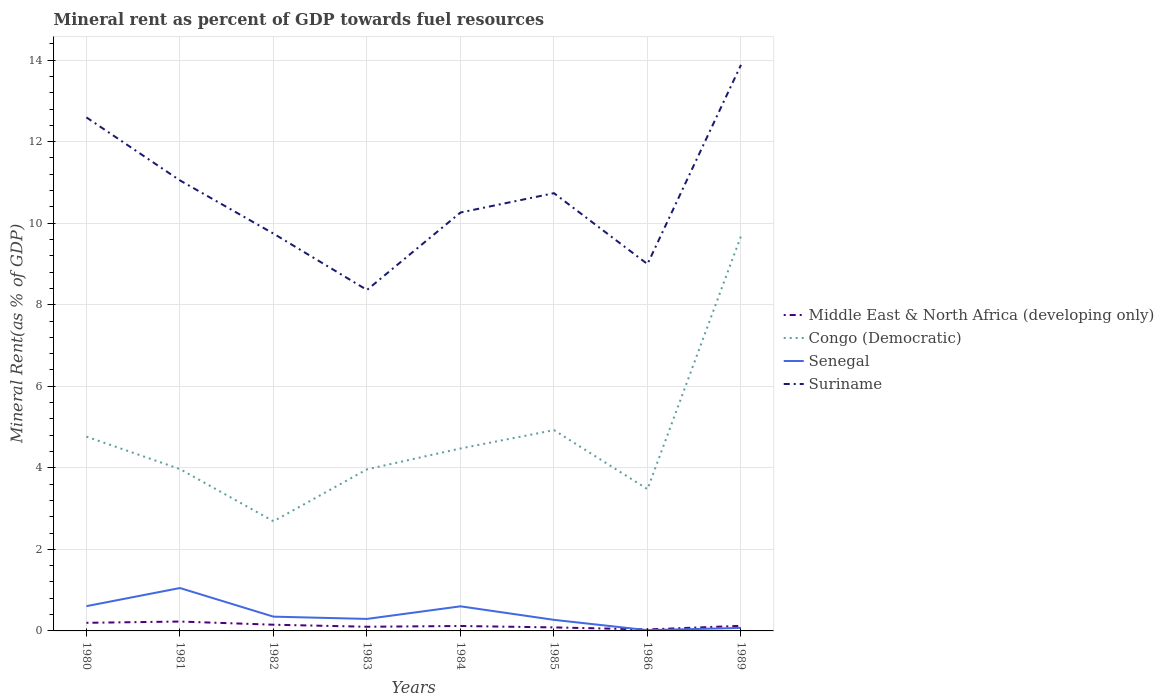How many different coloured lines are there?
Make the answer very short. 4. Is the number of lines equal to the number of legend labels?
Offer a very short reply. Yes. Across all years, what is the maximum mineral rent in Senegal?
Provide a succinct answer. 0.02. What is the total mineral rent in Middle East & North Africa (developing only) in the graph?
Provide a succinct answer. -0.02. What is the difference between the highest and the second highest mineral rent in Senegal?
Make the answer very short. 1.03. What is the difference between the highest and the lowest mineral rent in Senegal?
Offer a very short reply. 3. Does the graph contain any zero values?
Provide a succinct answer. No. Does the graph contain grids?
Offer a terse response. Yes. Where does the legend appear in the graph?
Offer a terse response. Center right. How many legend labels are there?
Provide a short and direct response. 4. How are the legend labels stacked?
Offer a very short reply. Vertical. What is the title of the graph?
Provide a short and direct response. Mineral rent as percent of GDP towards fuel resources. What is the label or title of the X-axis?
Offer a terse response. Years. What is the label or title of the Y-axis?
Make the answer very short. Mineral Rent(as % of GDP). What is the Mineral Rent(as % of GDP) of Middle East & North Africa (developing only) in 1980?
Make the answer very short. 0.2. What is the Mineral Rent(as % of GDP) in Congo (Democratic) in 1980?
Provide a short and direct response. 4.77. What is the Mineral Rent(as % of GDP) in Senegal in 1980?
Keep it short and to the point. 0.61. What is the Mineral Rent(as % of GDP) in Suriname in 1980?
Provide a succinct answer. 12.59. What is the Mineral Rent(as % of GDP) of Middle East & North Africa (developing only) in 1981?
Offer a terse response. 0.23. What is the Mineral Rent(as % of GDP) of Congo (Democratic) in 1981?
Your answer should be compact. 3.97. What is the Mineral Rent(as % of GDP) of Senegal in 1981?
Make the answer very short. 1.05. What is the Mineral Rent(as % of GDP) of Suriname in 1981?
Your response must be concise. 11.05. What is the Mineral Rent(as % of GDP) in Middle East & North Africa (developing only) in 1982?
Your answer should be compact. 0.15. What is the Mineral Rent(as % of GDP) of Congo (Democratic) in 1982?
Ensure brevity in your answer.  2.69. What is the Mineral Rent(as % of GDP) of Senegal in 1982?
Provide a short and direct response. 0.35. What is the Mineral Rent(as % of GDP) of Suriname in 1982?
Provide a short and direct response. 9.74. What is the Mineral Rent(as % of GDP) of Middle East & North Africa (developing only) in 1983?
Ensure brevity in your answer.  0.1. What is the Mineral Rent(as % of GDP) of Congo (Democratic) in 1983?
Offer a very short reply. 3.96. What is the Mineral Rent(as % of GDP) in Senegal in 1983?
Make the answer very short. 0.29. What is the Mineral Rent(as % of GDP) in Suriname in 1983?
Provide a short and direct response. 8.36. What is the Mineral Rent(as % of GDP) in Middle East & North Africa (developing only) in 1984?
Offer a very short reply. 0.12. What is the Mineral Rent(as % of GDP) of Congo (Democratic) in 1984?
Offer a terse response. 4.47. What is the Mineral Rent(as % of GDP) of Senegal in 1984?
Offer a very short reply. 0.6. What is the Mineral Rent(as % of GDP) of Suriname in 1984?
Provide a succinct answer. 10.26. What is the Mineral Rent(as % of GDP) in Middle East & North Africa (developing only) in 1985?
Provide a succinct answer. 0.09. What is the Mineral Rent(as % of GDP) of Congo (Democratic) in 1985?
Give a very brief answer. 4.92. What is the Mineral Rent(as % of GDP) of Senegal in 1985?
Your answer should be very brief. 0.27. What is the Mineral Rent(as % of GDP) in Suriname in 1985?
Keep it short and to the point. 10.74. What is the Mineral Rent(as % of GDP) of Middle East & North Africa (developing only) in 1986?
Your answer should be compact. 0.04. What is the Mineral Rent(as % of GDP) in Congo (Democratic) in 1986?
Provide a short and direct response. 3.48. What is the Mineral Rent(as % of GDP) of Senegal in 1986?
Make the answer very short. 0.02. What is the Mineral Rent(as % of GDP) in Suriname in 1986?
Give a very brief answer. 9. What is the Mineral Rent(as % of GDP) of Middle East & North Africa (developing only) in 1989?
Your response must be concise. 0.13. What is the Mineral Rent(as % of GDP) in Congo (Democratic) in 1989?
Provide a succinct answer. 9.68. What is the Mineral Rent(as % of GDP) in Senegal in 1989?
Provide a short and direct response. 0.07. What is the Mineral Rent(as % of GDP) in Suriname in 1989?
Provide a short and direct response. 13.88. Across all years, what is the maximum Mineral Rent(as % of GDP) of Middle East & North Africa (developing only)?
Your answer should be very brief. 0.23. Across all years, what is the maximum Mineral Rent(as % of GDP) of Congo (Democratic)?
Keep it short and to the point. 9.68. Across all years, what is the maximum Mineral Rent(as % of GDP) in Senegal?
Provide a short and direct response. 1.05. Across all years, what is the maximum Mineral Rent(as % of GDP) in Suriname?
Your answer should be compact. 13.88. Across all years, what is the minimum Mineral Rent(as % of GDP) of Middle East & North Africa (developing only)?
Keep it short and to the point. 0.04. Across all years, what is the minimum Mineral Rent(as % of GDP) in Congo (Democratic)?
Your answer should be very brief. 2.69. Across all years, what is the minimum Mineral Rent(as % of GDP) in Senegal?
Keep it short and to the point. 0.02. Across all years, what is the minimum Mineral Rent(as % of GDP) in Suriname?
Provide a succinct answer. 8.36. What is the total Mineral Rent(as % of GDP) in Middle East & North Africa (developing only) in the graph?
Offer a terse response. 1.05. What is the total Mineral Rent(as % of GDP) of Congo (Democratic) in the graph?
Keep it short and to the point. 37.95. What is the total Mineral Rent(as % of GDP) of Senegal in the graph?
Provide a succinct answer. 3.27. What is the total Mineral Rent(as % of GDP) of Suriname in the graph?
Give a very brief answer. 85.63. What is the difference between the Mineral Rent(as % of GDP) of Middle East & North Africa (developing only) in 1980 and that in 1981?
Offer a terse response. -0.03. What is the difference between the Mineral Rent(as % of GDP) in Congo (Democratic) in 1980 and that in 1981?
Give a very brief answer. 0.8. What is the difference between the Mineral Rent(as % of GDP) in Senegal in 1980 and that in 1981?
Offer a very short reply. -0.44. What is the difference between the Mineral Rent(as % of GDP) of Suriname in 1980 and that in 1981?
Your response must be concise. 1.55. What is the difference between the Mineral Rent(as % of GDP) of Middle East & North Africa (developing only) in 1980 and that in 1982?
Provide a short and direct response. 0.05. What is the difference between the Mineral Rent(as % of GDP) of Congo (Democratic) in 1980 and that in 1982?
Provide a succinct answer. 2.08. What is the difference between the Mineral Rent(as % of GDP) of Senegal in 1980 and that in 1982?
Your answer should be compact. 0.26. What is the difference between the Mineral Rent(as % of GDP) of Suriname in 1980 and that in 1982?
Offer a very short reply. 2.85. What is the difference between the Mineral Rent(as % of GDP) of Middle East & North Africa (developing only) in 1980 and that in 1983?
Provide a succinct answer. 0.1. What is the difference between the Mineral Rent(as % of GDP) in Congo (Democratic) in 1980 and that in 1983?
Give a very brief answer. 0.8. What is the difference between the Mineral Rent(as % of GDP) in Senegal in 1980 and that in 1983?
Offer a very short reply. 0.31. What is the difference between the Mineral Rent(as % of GDP) of Suriname in 1980 and that in 1983?
Your response must be concise. 4.23. What is the difference between the Mineral Rent(as % of GDP) of Middle East & North Africa (developing only) in 1980 and that in 1984?
Keep it short and to the point. 0.08. What is the difference between the Mineral Rent(as % of GDP) of Congo (Democratic) in 1980 and that in 1984?
Make the answer very short. 0.29. What is the difference between the Mineral Rent(as % of GDP) of Senegal in 1980 and that in 1984?
Your response must be concise. 0. What is the difference between the Mineral Rent(as % of GDP) in Suriname in 1980 and that in 1984?
Make the answer very short. 2.33. What is the difference between the Mineral Rent(as % of GDP) of Middle East & North Africa (developing only) in 1980 and that in 1985?
Make the answer very short. 0.11. What is the difference between the Mineral Rent(as % of GDP) of Congo (Democratic) in 1980 and that in 1985?
Your response must be concise. -0.16. What is the difference between the Mineral Rent(as % of GDP) of Senegal in 1980 and that in 1985?
Offer a terse response. 0.34. What is the difference between the Mineral Rent(as % of GDP) in Suriname in 1980 and that in 1985?
Give a very brief answer. 1.86. What is the difference between the Mineral Rent(as % of GDP) of Middle East & North Africa (developing only) in 1980 and that in 1986?
Provide a short and direct response. 0.16. What is the difference between the Mineral Rent(as % of GDP) of Congo (Democratic) in 1980 and that in 1986?
Provide a short and direct response. 1.29. What is the difference between the Mineral Rent(as % of GDP) in Senegal in 1980 and that in 1986?
Provide a succinct answer. 0.59. What is the difference between the Mineral Rent(as % of GDP) in Suriname in 1980 and that in 1986?
Offer a terse response. 3.6. What is the difference between the Mineral Rent(as % of GDP) of Middle East & North Africa (developing only) in 1980 and that in 1989?
Provide a short and direct response. 0.07. What is the difference between the Mineral Rent(as % of GDP) of Congo (Democratic) in 1980 and that in 1989?
Ensure brevity in your answer.  -4.92. What is the difference between the Mineral Rent(as % of GDP) in Senegal in 1980 and that in 1989?
Your answer should be compact. 0.53. What is the difference between the Mineral Rent(as % of GDP) in Suriname in 1980 and that in 1989?
Keep it short and to the point. -1.29. What is the difference between the Mineral Rent(as % of GDP) in Middle East & North Africa (developing only) in 1981 and that in 1982?
Your answer should be very brief. 0.08. What is the difference between the Mineral Rent(as % of GDP) in Congo (Democratic) in 1981 and that in 1982?
Provide a succinct answer. 1.28. What is the difference between the Mineral Rent(as % of GDP) in Senegal in 1981 and that in 1982?
Keep it short and to the point. 0.7. What is the difference between the Mineral Rent(as % of GDP) in Suriname in 1981 and that in 1982?
Offer a terse response. 1.3. What is the difference between the Mineral Rent(as % of GDP) in Middle East & North Africa (developing only) in 1981 and that in 1983?
Provide a short and direct response. 0.13. What is the difference between the Mineral Rent(as % of GDP) of Congo (Democratic) in 1981 and that in 1983?
Provide a succinct answer. 0.01. What is the difference between the Mineral Rent(as % of GDP) in Senegal in 1981 and that in 1983?
Your response must be concise. 0.76. What is the difference between the Mineral Rent(as % of GDP) in Suriname in 1981 and that in 1983?
Offer a terse response. 2.69. What is the difference between the Mineral Rent(as % of GDP) in Middle East & North Africa (developing only) in 1981 and that in 1984?
Your response must be concise. 0.11. What is the difference between the Mineral Rent(as % of GDP) in Congo (Democratic) in 1981 and that in 1984?
Give a very brief answer. -0.51. What is the difference between the Mineral Rent(as % of GDP) of Senegal in 1981 and that in 1984?
Offer a terse response. 0.45. What is the difference between the Mineral Rent(as % of GDP) of Suriname in 1981 and that in 1984?
Make the answer very short. 0.79. What is the difference between the Mineral Rent(as % of GDP) of Middle East & North Africa (developing only) in 1981 and that in 1985?
Make the answer very short. 0.14. What is the difference between the Mineral Rent(as % of GDP) of Congo (Democratic) in 1981 and that in 1985?
Your response must be concise. -0.95. What is the difference between the Mineral Rent(as % of GDP) in Senegal in 1981 and that in 1985?
Offer a very short reply. 0.78. What is the difference between the Mineral Rent(as % of GDP) of Suriname in 1981 and that in 1985?
Ensure brevity in your answer.  0.31. What is the difference between the Mineral Rent(as % of GDP) of Middle East & North Africa (developing only) in 1981 and that in 1986?
Offer a very short reply. 0.19. What is the difference between the Mineral Rent(as % of GDP) of Congo (Democratic) in 1981 and that in 1986?
Your answer should be very brief. 0.49. What is the difference between the Mineral Rent(as % of GDP) of Senegal in 1981 and that in 1986?
Your answer should be very brief. 1.03. What is the difference between the Mineral Rent(as % of GDP) in Suriname in 1981 and that in 1986?
Offer a terse response. 2.05. What is the difference between the Mineral Rent(as % of GDP) in Middle East & North Africa (developing only) in 1981 and that in 1989?
Offer a terse response. 0.1. What is the difference between the Mineral Rent(as % of GDP) of Congo (Democratic) in 1981 and that in 1989?
Provide a succinct answer. -5.71. What is the difference between the Mineral Rent(as % of GDP) in Senegal in 1981 and that in 1989?
Keep it short and to the point. 0.98. What is the difference between the Mineral Rent(as % of GDP) of Suriname in 1981 and that in 1989?
Your answer should be compact. -2.83. What is the difference between the Mineral Rent(as % of GDP) of Middle East & North Africa (developing only) in 1982 and that in 1983?
Make the answer very short. 0.05. What is the difference between the Mineral Rent(as % of GDP) in Congo (Democratic) in 1982 and that in 1983?
Make the answer very short. -1.27. What is the difference between the Mineral Rent(as % of GDP) in Senegal in 1982 and that in 1983?
Provide a short and direct response. 0.06. What is the difference between the Mineral Rent(as % of GDP) in Suriname in 1982 and that in 1983?
Keep it short and to the point. 1.38. What is the difference between the Mineral Rent(as % of GDP) in Middle East & North Africa (developing only) in 1982 and that in 1984?
Offer a terse response. 0.03. What is the difference between the Mineral Rent(as % of GDP) of Congo (Democratic) in 1982 and that in 1984?
Offer a very short reply. -1.79. What is the difference between the Mineral Rent(as % of GDP) of Senegal in 1982 and that in 1984?
Provide a short and direct response. -0.25. What is the difference between the Mineral Rent(as % of GDP) in Suriname in 1982 and that in 1984?
Your answer should be very brief. -0.52. What is the difference between the Mineral Rent(as % of GDP) in Middle East & North Africa (developing only) in 1982 and that in 1985?
Give a very brief answer. 0.07. What is the difference between the Mineral Rent(as % of GDP) of Congo (Democratic) in 1982 and that in 1985?
Make the answer very short. -2.24. What is the difference between the Mineral Rent(as % of GDP) in Senegal in 1982 and that in 1985?
Offer a very short reply. 0.08. What is the difference between the Mineral Rent(as % of GDP) of Suriname in 1982 and that in 1985?
Give a very brief answer. -0.99. What is the difference between the Mineral Rent(as % of GDP) in Middle East & North Africa (developing only) in 1982 and that in 1986?
Your answer should be compact. 0.12. What is the difference between the Mineral Rent(as % of GDP) in Congo (Democratic) in 1982 and that in 1986?
Offer a terse response. -0.79. What is the difference between the Mineral Rent(as % of GDP) in Senegal in 1982 and that in 1986?
Your response must be concise. 0.33. What is the difference between the Mineral Rent(as % of GDP) of Suriname in 1982 and that in 1986?
Keep it short and to the point. 0.75. What is the difference between the Mineral Rent(as % of GDP) of Middle East & North Africa (developing only) in 1982 and that in 1989?
Make the answer very short. 0.03. What is the difference between the Mineral Rent(as % of GDP) of Congo (Democratic) in 1982 and that in 1989?
Your answer should be compact. -6.99. What is the difference between the Mineral Rent(as % of GDP) in Senegal in 1982 and that in 1989?
Offer a very short reply. 0.28. What is the difference between the Mineral Rent(as % of GDP) of Suriname in 1982 and that in 1989?
Provide a succinct answer. -4.14. What is the difference between the Mineral Rent(as % of GDP) of Middle East & North Africa (developing only) in 1983 and that in 1984?
Ensure brevity in your answer.  -0.02. What is the difference between the Mineral Rent(as % of GDP) of Congo (Democratic) in 1983 and that in 1984?
Offer a very short reply. -0.51. What is the difference between the Mineral Rent(as % of GDP) of Senegal in 1983 and that in 1984?
Provide a succinct answer. -0.31. What is the difference between the Mineral Rent(as % of GDP) of Suriname in 1983 and that in 1984?
Your response must be concise. -1.9. What is the difference between the Mineral Rent(as % of GDP) in Middle East & North Africa (developing only) in 1983 and that in 1985?
Make the answer very short. 0.02. What is the difference between the Mineral Rent(as % of GDP) of Congo (Democratic) in 1983 and that in 1985?
Your answer should be compact. -0.96. What is the difference between the Mineral Rent(as % of GDP) of Senegal in 1983 and that in 1985?
Your response must be concise. 0.02. What is the difference between the Mineral Rent(as % of GDP) of Suriname in 1983 and that in 1985?
Provide a succinct answer. -2.37. What is the difference between the Mineral Rent(as % of GDP) of Middle East & North Africa (developing only) in 1983 and that in 1986?
Provide a succinct answer. 0.07. What is the difference between the Mineral Rent(as % of GDP) of Congo (Democratic) in 1983 and that in 1986?
Offer a very short reply. 0.49. What is the difference between the Mineral Rent(as % of GDP) in Senegal in 1983 and that in 1986?
Your response must be concise. 0.28. What is the difference between the Mineral Rent(as % of GDP) of Suriname in 1983 and that in 1986?
Your response must be concise. -0.64. What is the difference between the Mineral Rent(as % of GDP) of Middle East & North Africa (developing only) in 1983 and that in 1989?
Provide a short and direct response. -0.02. What is the difference between the Mineral Rent(as % of GDP) in Congo (Democratic) in 1983 and that in 1989?
Your answer should be very brief. -5.72. What is the difference between the Mineral Rent(as % of GDP) in Senegal in 1983 and that in 1989?
Provide a short and direct response. 0.22. What is the difference between the Mineral Rent(as % of GDP) of Suriname in 1983 and that in 1989?
Keep it short and to the point. -5.52. What is the difference between the Mineral Rent(as % of GDP) in Middle East & North Africa (developing only) in 1984 and that in 1985?
Make the answer very short. 0.03. What is the difference between the Mineral Rent(as % of GDP) of Congo (Democratic) in 1984 and that in 1985?
Ensure brevity in your answer.  -0.45. What is the difference between the Mineral Rent(as % of GDP) in Senegal in 1984 and that in 1985?
Offer a terse response. 0.33. What is the difference between the Mineral Rent(as % of GDP) of Suriname in 1984 and that in 1985?
Ensure brevity in your answer.  -0.47. What is the difference between the Mineral Rent(as % of GDP) of Middle East & North Africa (developing only) in 1984 and that in 1986?
Give a very brief answer. 0.08. What is the difference between the Mineral Rent(as % of GDP) of Senegal in 1984 and that in 1986?
Your answer should be compact. 0.59. What is the difference between the Mineral Rent(as % of GDP) of Suriname in 1984 and that in 1986?
Provide a succinct answer. 1.26. What is the difference between the Mineral Rent(as % of GDP) in Middle East & North Africa (developing only) in 1984 and that in 1989?
Your answer should be very brief. -0. What is the difference between the Mineral Rent(as % of GDP) in Congo (Democratic) in 1984 and that in 1989?
Your response must be concise. -5.21. What is the difference between the Mineral Rent(as % of GDP) of Senegal in 1984 and that in 1989?
Your answer should be very brief. 0.53. What is the difference between the Mineral Rent(as % of GDP) of Suriname in 1984 and that in 1989?
Offer a very short reply. -3.62. What is the difference between the Mineral Rent(as % of GDP) of Middle East & North Africa (developing only) in 1985 and that in 1986?
Your answer should be compact. 0.05. What is the difference between the Mineral Rent(as % of GDP) of Congo (Democratic) in 1985 and that in 1986?
Make the answer very short. 1.45. What is the difference between the Mineral Rent(as % of GDP) of Senegal in 1985 and that in 1986?
Make the answer very short. 0.25. What is the difference between the Mineral Rent(as % of GDP) of Suriname in 1985 and that in 1986?
Your answer should be very brief. 1.74. What is the difference between the Mineral Rent(as % of GDP) in Middle East & North Africa (developing only) in 1985 and that in 1989?
Make the answer very short. -0.04. What is the difference between the Mineral Rent(as % of GDP) in Congo (Democratic) in 1985 and that in 1989?
Provide a short and direct response. -4.76. What is the difference between the Mineral Rent(as % of GDP) in Senegal in 1985 and that in 1989?
Provide a short and direct response. 0.2. What is the difference between the Mineral Rent(as % of GDP) in Suriname in 1985 and that in 1989?
Offer a terse response. -3.15. What is the difference between the Mineral Rent(as % of GDP) of Middle East & North Africa (developing only) in 1986 and that in 1989?
Make the answer very short. -0.09. What is the difference between the Mineral Rent(as % of GDP) in Congo (Democratic) in 1986 and that in 1989?
Ensure brevity in your answer.  -6.21. What is the difference between the Mineral Rent(as % of GDP) in Senegal in 1986 and that in 1989?
Make the answer very short. -0.06. What is the difference between the Mineral Rent(as % of GDP) in Suriname in 1986 and that in 1989?
Provide a short and direct response. -4.89. What is the difference between the Mineral Rent(as % of GDP) in Middle East & North Africa (developing only) in 1980 and the Mineral Rent(as % of GDP) in Congo (Democratic) in 1981?
Your response must be concise. -3.77. What is the difference between the Mineral Rent(as % of GDP) of Middle East & North Africa (developing only) in 1980 and the Mineral Rent(as % of GDP) of Senegal in 1981?
Provide a succinct answer. -0.85. What is the difference between the Mineral Rent(as % of GDP) in Middle East & North Africa (developing only) in 1980 and the Mineral Rent(as % of GDP) in Suriname in 1981?
Make the answer very short. -10.85. What is the difference between the Mineral Rent(as % of GDP) of Congo (Democratic) in 1980 and the Mineral Rent(as % of GDP) of Senegal in 1981?
Give a very brief answer. 3.71. What is the difference between the Mineral Rent(as % of GDP) in Congo (Democratic) in 1980 and the Mineral Rent(as % of GDP) in Suriname in 1981?
Your answer should be compact. -6.28. What is the difference between the Mineral Rent(as % of GDP) in Senegal in 1980 and the Mineral Rent(as % of GDP) in Suriname in 1981?
Provide a short and direct response. -10.44. What is the difference between the Mineral Rent(as % of GDP) in Middle East & North Africa (developing only) in 1980 and the Mineral Rent(as % of GDP) in Congo (Democratic) in 1982?
Give a very brief answer. -2.49. What is the difference between the Mineral Rent(as % of GDP) in Middle East & North Africa (developing only) in 1980 and the Mineral Rent(as % of GDP) in Senegal in 1982?
Your answer should be very brief. -0.15. What is the difference between the Mineral Rent(as % of GDP) of Middle East & North Africa (developing only) in 1980 and the Mineral Rent(as % of GDP) of Suriname in 1982?
Your response must be concise. -9.55. What is the difference between the Mineral Rent(as % of GDP) of Congo (Democratic) in 1980 and the Mineral Rent(as % of GDP) of Senegal in 1982?
Provide a succinct answer. 4.42. What is the difference between the Mineral Rent(as % of GDP) of Congo (Democratic) in 1980 and the Mineral Rent(as % of GDP) of Suriname in 1982?
Offer a terse response. -4.98. What is the difference between the Mineral Rent(as % of GDP) of Senegal in 1980 and the Mineral Rent(as % of GDP) of Suriname in 1982?
Your answer should be compact. -9.14. What is the difference between the Mineral Rent(as % of GDP) in Middle East & North Africa (developing only) in 1980 and the Mineral Rent(as % of GDP) in Congo (Democratic) in 1983?
Your response must be concise. -3.76. What is the difference between the Mineral Rent(as % of GDP) in Middle East & North Africa (developing only) in 1980 and the Mineral Rent(as % of GDP) in Senegal in 1983?
Your answer should be very brief. -0.1. What is the difference between the Mineral Rent(as % of GDP) of Middle East & North Africa (developing only) in 1980 and the Mineral Rent(as % of GDP) of Suriname in 1983?
Ensure brevity in your answer.  -8.16. What is the difference between the Mineral Rent(as % of GDP) in Congo (Democratic) in 1980 and the Mineral Rent(as % of GDP) in Senegal in 1983?
Your answer should be very brief. 4.47. What is the difference between the Mineral Rent(as % of GDP) of Congo (Democratic) in 1980 and the Mineral Rent(as % of GDP) of Suriname in 1983?
Your answer should be very brief. -3.6. What is the difference between the Mineral Rent(as % of GDP) in Senegal in 1980 and the Mineral Rent(as % of GDP) in Suriname in 1983?
Your answer should be compact. -7.75. What is the difference between the Mineral Rent(as % of GDP) in Middle East & North Africa (developing only) in 1980 and the Mineral Rent(as % of GDP) in Congo (Democratic) in 1984?
Your answer should be compact. -4.28. What is the difference between the Mineral Rent(as % of GDP) in Middle East & North Africa (developing only) in 1980 and the Mineral Rent(as % of GDP) in Senegal in 1984?
Offer a very short reply. -0.4. What is the difference between the Mineral Rent(as % of GDP) of Middle East & North Africa (developing only) in 1980 and the Mineral Rent(as % of GDP) of Suriname in 1984?
Make the answer very short. -10.06. What is the difference between the Mineral Rent(as % of GDP) of Congo (Democratic) in 1980 and the Mineral Rent(as % of GDP) of Senegal in 1984?
Offer a terse response. 4.16. What is the difference between the Mineral Rent(as % of GDP) of Congo (Democratic) in 1980 and the Mineral Rent(as % of GDP) of Suriname in 1984?
Your answer should be very brief. -5.5. What is the difference between the Mineral Rent(as % of GDP) of Senegal in 1980 and the Mineral Rent(as % of GDP) of Suriname in 1984?
Ensure brevity in your answer.  -9.65. What is the difference between the Mineral Rent(as % of GDP) in Middle East & North Africa (developing only) in 1980 and the Mineral Rent(as % of GDP) in Congo (Democratic) in 1985?
Provide a short and direct response. -4.73. What is the difference between the Mineral Rent(as % of GDP) of Middle East & North Africa (developing only) in 1980 and the Mineral Rent(as % of GDP) of Senegal in 1985?
Your response must be concise. -0.07. What is the difference between the Mineral Rent(as % of GDP) in Middle East & North Africa (developing only) in 1980 and the Mineral Rent(as % of GDP) in Suriname in 1985?
Ensure brevity in your answer.  -10.54. What is the difference between the Mineral Rent(as % of GDP) in Congo (Democratic) in 1980 and the Mineral Rent(as % of GDP) in Senegal in 1985?
Make the answer very short. 4.49. What is the difference between the Mineral Rent(as % of GDP) in Congo (Democratic) in 1980 and the Mineral Rent(as % of GDP) in Suriname in 1985?
Give a very brief answer. -5.97. What is the difference between the Mineral Rent(as % of GDP) of Senegal in 1980 and the Mineral Rent(as % of GDP) of Suriname in 1985?
Offer a very short reply. -10.13. What is the difference between the Mineral Rent(as % of GDP) in Middle East & North Africa (developing only) in 1980 and the Mineral Rent(as % of GDP) in Congo (Democratic) in 1986?
Your answer should be very brief. -3.28. What is the difference between the Mineral Rent(as % of GDP) of Middle East & North Africa (developing only) in 1980 and the Mineral Rent(as % of GDP) of Senegal in 1986?
Your answer should be compact. 0.18. What is the difference between the Mineral Rent(as % of GDP) of Middle East & North Africa (developing only) in 1980 and the Mineral Rent(as % of GDP) of Suriname in 1986?
Ensure brevity in your answer.  -8.8. What is the difference between the Mineral Rent(as % of GDP) of Congo (Democratic) in 1980 and the Mineral Rent(as % of GDP) of Senegal in 1986?
Your response must be concise. 4.75. What is the difference between the Mineral Rent(as % of GDP) of Congo (Democratic) in 1980 and the Mineral Rent(as % of GDP) of Suriname in 1986?
Offer a very short reply. -4.23. What is the difference between the Mineral Rent(as % of GDP) of Senegal in 1980 and the Mineral Rent(as % of GDP) of Suriname in 1986?
Keep it short and to the point. -8.39. What is the difference between the Mineral Rent(as % of GDP) in Middle East & North Africa (developing only) in 1980 and the Mineral Rent(as % of GDP) in Congo (Democratic) in 1989?
Offer a very short reply. -9.48. What is the difference between the Mineral Rent(as % of GDP) of Middle East & North Africa (developing only) in 1980 and the Mineral Rent(as % of GDP) of Senegal in 1989?
Make the answer very short. 0.12. What is the difference between the Mineral Rent(as % of GDP) of Middle East & North Africa (developing only) in 1980 and the Mineral Rent(as % of GDP) of Suriname in 1989?
Keep it short and to the point. -13.68. What is the difference between the Mineral Rent(as % of GDP) in Congo (Democratic) in 1980 and the Mineral Rent(as % of GDP) in Senegal in 1989?
Provide a short and direct response. 4.69. What is the difference between the Mineral Rent(as % of GDP) in Congo (Democratic) in 1980 and the Mineral Rent(as % of GDP) in Suriname in 1989?
Give a very brief answer. -9.12. What is the difference between the Mineral Rent(as % of GDP) in Senegal in 1980 and the Mineral Rent(as % of GDP) in Suriname in 1989?
Provide a succinct answer. -13.28. What is the difference between the Mineral Rent(as % of GDP) in Middle East & North Africa (developing only) in 1981 and the Mineral Rent(as % of GDP) in Congo (Democratic) in 1982?
Your answer should be compact. -2.46. What is the difference between the Mineral Rent(as % of GDP) of Middle East & North Africa (developing only) in 1981 and the Mineral Rent(as % of GDP) of Senegal in 1982?
Give a very brief answer. -0.12. What is the difference between the Mineral Rent(as % of GDP) of Middle East & North Africa (developing only) in 1981 and the Mineral Rent(as % of GDP) of Suriname in 1982?
Ensure brevity in your answer.  -9.51. What is the difference between the Mineral Rent(as % of GDP) of Congo (Democratic) in 1981 and the Mineral Rent(as % of GDP) of Senegal in 1982?
Your answer should be compact. 3.62. What is the difference between the Mineral Rent(as % of GDP) in Congo (Democratic) in 1981 and the Mineral Rent(as % of GDP) in Suriname in 1982?
Offer a terse response. -5.78. What is the difference between the Mineral Rent(as % of GDP) of Senegal in 1981 and the Mineral Rent(as % of GDP) of Suriname in 1982?
Your response must be concise. -8.69. What is the difference between the Mineral Rent(as % of GDP) in Middle East & North Africa (developing only) in 1981 and the Mineral Rent(as % of GDP) in Congo (Democratic) in 1983?
Your response must be concise. -3.73. What is the difference between the Mineral Rent(as % of GDP) in Middle East & North Africa (developing only) in 1981 and the Mineral Rent(as % of GDP) in Senegal in 1983?
Your answer should be very brief. -0.06. What is the difference between the Mineral Rent(as % of GDP) of Middle East & North Africa (developing only) in 1981 and the Mineral Rent(as % of GDP) of Suriname in 1983?
Offer a terse response. -8.13. What is the difference between the Mineral Rent(as % of GDP) of Congo (Democratic) in 1981 and the Mineral Rent(as % of GDP) of Senegal in 1983?
Offer a terse response. 3.68. What is the difference between the Mineral Rent(as % of GDP) of Congo (Democratic) in 1981 and the Mineral Rent(as % of GDP) of Suriname in 1983?
Your response must be concise. -4.39. What is the difference between the Mineral Rent(as % of GDP) in Senegal in 1981 and the Mineral Rent(as % of GDP) in Suriname in 1983?
Your answer should be very brief. -7.31. What is the difference between the Mineral Rent(as % of GDP) of Middle East & North Africa (developing only) in 1981 and the Mineral Rent(as % of GDP) of Congo (Democratic) in 1984?
Your answer should be very brief. -4.24. What is the difference between the Mineral Rent(as % of GDP) of Middle East & North Africa (developing only) in 1981 and the Mineral Rent(as % of GDP) of Senegal in 1984?
Keep it short and to the point. -0.37. What is the difference between the Mineral Rent(as % of GDP) of Middle East & North Africa (developing only) in 1981 and the Mineral Rent(as % of GDP) of Suriname in 1984?
Provide a short and direct response. -10.03. What is the difference between the Mineral Rent(as % of GDP) in Congo (Democratic) in 1981 and the Mineral Rent(as % of GDP) in Senegal in 1984?
Make the answer very short. 3.37. What is the difference between the Mineral Rent(as % of GDP) in Congo (Democratic) in 1981 and the Mineral Rent(as % of GDP) in Suriname in 1984?
Your response must be concise. -6.29. What is the difference between the Mineral Rent(as % of GDP) of Senegal in 1981 and the Mineral Rent(as % of GDP) of Suriname in 1984?
Keep it short and to the point. -9.21. What is the difference between the Mineral Rent(as % of GDP) in Middle East & North Africa (developing only) in 1981 and the Mineral Rent(as % of GDP) in Congo (Democratic) in 1985?
Ensure brevity in your answer.  -4.69. What is the difference between the Mineral Rent(as % of GDP) of Middle East & North Africa (developing only) in 1981 and the Mineral Rent(as % of GDP) of Senegal in 1985?
Your answer should be compact. -0.04. What is the difference between the Mineral Rent(as % of GDP) of Middle East & North Africa (developing only) in 1981 and the Mineral Rent(as % of GDP) of Suriname in 1985?
Provide a succinct answer. -10.51. What is the difference between the Mineral Rent(as % of GDP) in Congo (Democratic) in 1981 and the Mineral Rent(as % of GDP) in Senegal in 1985?
Give a very brief answer. 3.7. What is the difference between the Mineral Rent(as % of GDP) in Congo (Democratic) in 1981 and the Mineral Rent(as % of GDP) in Suriname in 1985?
Make the answer very short. -6.77. What is the difference between the Mineral Rent(as % of GDP) of Senegal in 1981 and the Mineral Rent(as % of GDP) of Suriname in 1985?
Make the answer very short. -9.68. What is the difference between the Mineral Rent(as % of GDP) in Middle East & North Africa (developing only) in 1981 and the Mineral Rent(as % of GDP) in Congo (Democratic) in 1986?
Provide a succinct answer. -3.25. What is the difference between the Mineral Rent(as % of GDP) in Middle East & North Africa (developing only) in 1981 and the Mineral Rent(as % of GDP) in Senegal in 1986?
Provide a short and direct response. 0.21. What is the difference between the Mineral Rent(as % of GDP) in Middle East & North Africa (developing only) in 1981 and the Mineral Rent(as % of GDP) in Suriname in 1986?
Give a very brief answer. -8.77. What is the difference between the Mineral Rent(as % of GDP) of Congo (Democratic) in 1981 and the Mineral Rent(as % of GDP) of Senegal in 1986?
Offer a very short reply. 3.95. What is the difference between the Mineral Rent(as % of GDP) of Congo (Democratic) in 1981 and the Mineral Rent(as % of GDP) of Suriname in 1986?
Your answer should be very brief. -5.03. What is the difference between the Mineral Rent(as % of GDP) in Senegal in 1981 and the Mineral Rent(as % of GDP) in Suriname in 1986?
Offer a very short reply. -7.95. What is the difference between the Mineral Rent(as % of GDP) of Middle East & North Africa (developing only) in 1981 and the Mineral Rent(as % of GDP) of Congo (Democratic) in 1989?
Offer a very short reply. -9.45. What is the difference between the Mineral Rent(as % of GDP) in Middle East & North Africa (developing only) in 1981 and the Mineral Rent(as % of GDP) in Senegal in 1989?
Provide a succinct answer. 0.16. What is the difference between the Mineral Rent(as % of GDP) in Middle East & North Africa (developing only) in 1981 and the Mineral Rent(as % of GDP) in Suriname in 1989?
Your answer should be compact. -13.65. What is the difference between the Mineral Rent(as % of GDP) in Congo (Democratic) in 1981 and the Mineral Rent(as % of GDP) in Senegal in 1989?
Your answer should be very brief. 3.9. What is the difference between the Mineral Rent(as % of GDP) of Congo (Democratic) in 1981 and the Mineral Rent(as % of GDP) of Suriname in 1989?
Offer a terse response. -9.91. What is the difference between the Mineral Rent(as % of GDP) in Senegal in 1981 and the Mineral Rent(as % of GDP) in Suriname in 1989?
Give a very brief answer. -12.83. What is the difference between the Mineral Rent(as % of GDP) of Middle East & North Africa (developing only) in 1982 and the Mineral Rent(as % of GDP) of Congo (Democratic) in 1983?
Provide a short and direct response. -3.81. What is the difference between the Mineral Rent(as % of GDP) in Middle East & North Africa (developing only) in 1982 and the Mineral Rent(as % of GDP) in Senegal in 1983?
Your response must be concise. -0.14. What is the difference between the Mineral Rent(as % of GDP) of Middle East & North Africa (developing only) in 1982 and the Mineral Rent(as % of GDP) of Suriname in 1983?
Offer a terse response. -8.21. What is the difference between the Mineral Rent(as % of GDP) in Congo (Democratic) in 1982 and the Mineral Rent(as % of GDP) in Senegal in 1983?
Provide a short and direct response. 2.39. What is the difference between the Mineral Rent(as % of GDP) in Congo (Democratic) in 1982 and the Mineral Rent(as % of GDP) in Suriname in 1983?
Provide a succinct answer. -5.67. What is the difference between the Mineral Rent(as % of GDP) of Senegal in 1982 and the Mineral Rent(as % of GDP) of Suriname in 1983?
Ensure brevity in your answer.  -8.01. What is the difference between the Mineral Rent(as % of GDP) of Middle East & North Africa (developing only) in 1982 and the Mineral Rent(as % of GDP) of Congo (Democratic) in 1984?
Offer a terse response. -4.32. What is the difference between the Mineral Rent(as % of GDP) of Middle East & North Africa (developing only) in 1982 and the Mineral Rent(as % of GDP) of Senegal in 1984?
Give a very brief answer. -0.45. What is the difference between the Mineral Rent(as % of GDP) of Middle East & North Africa (developing only) in 1982 and the Mineral Rent(as % of GDP) of Suriname in 1984?
Provide a short and direct response. -10.11. What is the difference between the Mineral Rent(as % of GDP) in Congo (Democratic) in 1982 and the Mineral Rent(as % of GDP) in Senegal in 1984?
Your response must be concise. 2.09. What is the difference between the Mineral Rent(as % of GDP) of Congo (Democratic) in 1982 and the Mineral Rent(as % of GDP) of Suriname in 1984?
Keep it short and to the point. -7.57. What is the difference between the Mineral Rent(as % of GDP) of Senegal in 1982 and the Mineral Rent(as % of GDP) of Suriname in 1984?
Provide a short and direct response. -9.91. What is the difference between the Mineral Rent(as % of GDP) of Middle East & North Africa (developing only) in 1982 and the Mineral Rent(as % of GDP) of Congo (Democratic) in 1985?
Ensure brevity in your answer.  -4.77. What is the difference between the Mineral Rent(as % of GDP) of Middle East & North Africa (developing only) in 1982 and the Mineral Rent(as % of GDP) of Senegal in 1985?
Offer a very short reply. -0.12. What is the difference between the Mineral Rent(as % of GDP) of Middle East & North Africa (developing only) in 1982 and the Mineral Rent(as % of GDP) of Suriname in 1985?
Keep it short and to the point. -10.58. What is the difference between the Mineral Rent(as % of GDP) of Congo (Democratic) in 1982 and the Mineral Rent(as % of GDP) of Senegal in 1985?
Offer a very short reply. 2.42. What is the difference between the Mineral Rent(as % of GDP) in Congo (Democratic) in 1982 and the Mineral Rent(as % of GDP) in Suriname in 1985?
Make the answer very short. -8.05. What is the difference between the Mineral Rent(as % of GDP) of Senegal in 1982 and the Mineral Rent(as % of GDP) of Suriname in 1985?
Provide a succinct answer. -10.39. What is the difference between the Mineral Rent(as % of GDP) of Middle East & North Africa (developing only) in 1982 and the Mineral Rent(as % of GDP) of Congo (Democratic) in 1986?
Your answer should be very brief. -3.32. What is the difference between the Mineral Rent(as % of GDP) of Middle East & North Africa (developing only) in 1982 and the Mineral Rent(as % of GDP) of Senegal in 1986?
Offer a terse response. 0.13. What is the difference between the Mineral Rent(as % of GDP) of Middle East & North Africa (developing only) in 1982 and the Mineral Rent(as % of GDP) of Suriname in 1986?
Give a very brief answer. -8.84. What is the difference between the Mineral Rent(as % of GDP) of Congo (Democratic) in 1982 and the Mineral Rent(as % of GDP) of Senegal in 1986?
Your answer should be compact. 2.67. What is the difference between the Mineral Rent(as % of GDP) in Congo (Democratic) in 1982 and the Mineral Rent(as % of GDP) in Suriname in 1986?
Ensure brevity in your answer.  -6.31. What is the difference between the Mineral Rent(as % of GDP) of Senegal in 1982 and the Mineral Rent(as % of GDP) of Suriname in 1986?
Your answer should be compact. -8.65. What is the difference between the Mineral Rent(as % of GDP) in Middle East & North Africa (developing only) in 1982 and the Mineral Rent(as % of GDP) in Congo (Democratic) in 1989?
Your answer should be very brief. -9.53. What is the difference between the Mineral Rent(as % of GDP) of Middle East & North Africa (developing only) in 1982 and the Mineral Rent(as % of GDP) of Senegal in 1989?
Your answer should be compact. 0.08. What is the difference between the Mineral Rent(as % of GDP) of Middle East & North Africa (developing only) in 1982 and the Mineral Rent(as % of GDP) of Suriname in 1989?
Make the answer very short. -13.73. What is the difference between the Mineral Rent(as % of GDP) of Congo (Democratic) in 1982 and the Mineral Rent(as % of GDP) of Senegal in 1989?
Offer a terse response. 2.62. What is the difference between the Mineral Rent(as % of GDP) of Congo (Democratic) in 1982 and the Mineral Rent(as % of GDP) of Suriname in 1989?
Your answer should be compact. -11.19. What is the difference between the Mineral Rent(as % of GDP) of Senegal in 1982 and the Mineral Rent(as % of GDP) of Suriname in 1989?
Keep it short and to the point. -13.53. What is the difference between the Mineral Rent(as % of GDP) of Middle East & North Africa (developing only) in 1983 and the Mineral Rent(as % of GDP) of Congo (Democratic) in 1984?
Ensure brevity in your answer.  -4.37. What is the difference between the Mineral Rent(as % of GDP) of Middle East & North Africa (developing only) in 1983 and the Mineral Rent(as % of GDP) of Senegal in 1984?
Provide a short and direct response. -0.5. What is the difference between the Mineral Rent(as % of GDP) of Middle East & North Africa (developing only) in 1983 and the Mineral Rent(as % of GDP) of Suriname in 1984?
Give a very brief answer. -10.16. What is the difference between the Mineral Rent(as % of GDP) in Congo (Democratic) in 1983 and the Mineral Rent(as % of GDP) in Senegal in 1984?
Your answer should be very brief. 3.36. What is the difference between the Mineral Rent(as % of GDP) of Congo (Democratic) in 1983 and the Mineral Rent(as % of GDP) of Suriname in 1984?
Your answer should be very brief. -6.3. What is the difference between the Mineral Rent(as % of GDP) in Senegal in 1983 and the Mineral Rent(as % of GDP) in Suriname in 1984?
Offer a terse response. -9.97. What is the difference between the Mineral Rent(as % of GDP) of Middle East & North Africa (developing only) in 1983 and the Mineral Rent(as % of GDP) of Congo (Democratic) in 1985?
Your response must be concise. -4.82. What is the difference between the Mineral Rent(as % of GDP) of Middle East & North Africa (developing only) in 1983 and the Mineral Rent(as % of GDP) of Senegal in 1985?
Offer a terse response. -0.17. What is the difference between the Mineral Rent(as % of GDP) in Middle East & North Africa (developing only) in 1983 and the Mineral Rent(as % of GDP) in Suriname in 1985?
Make the answer very short. -10.63. What is the difference between the Mineral Rent(as % of GDP) of Congo (Democratic) in 1983 and the Mineral Rent(as % of GDP) of Senegal in 1985?
Your answer should be very brief. 3.69. What is the difference between the Mineral Rent(as % of GDP) of Congo (Democratic) in 1983 and the Mineral Rent(as % of GDP) of Suriname in 1985?
Your answer should be very brief. -6.77. What is the difference between the Mineral Rent(as % of GDP) in Senegal in 1983 and the Mineral Rent(as % of GDP) in Suriname in 1985?
Provide a short and direct response. -10.44. What is the difference between the Mineral Rent(as % of GDP) of Middle East & North Africa (developing only) in 1983 and the Mineral Rent(as % of GDP) of Congo (Democratic) in 1986?
Your answer should be very brief. -3.37. What is the difference between the Mineral Rent(as % of GDP) in Middle East & North Africa (developing only) in 1983 and the Mineral Rent(as % of GDP) in Senegal in 1986?
Provide a short and direct response. 0.08. What is the difference between the Mineral Rent(as % of GDP) of Middle East & North Africa (developing only) in 1983 and the Mineral Rent(as % of GDP) of Suriname in 1986?
Your answer should be compact. -8.89. What is the difference between the Mineral Rent(as % of GDP) of Congo (Democratic) in 1983 and the Mineral Rent(as % of GDP) of Senegal in 1986?
Ensure brevity in your answer.  3.94. What is the difference between the Mineral Rent(as % of GDP) in Congo (Democratic) in 1983 and the Mineral Rent(as % of GDP) in Suriname in 1986?
Give a very brief answer. -5.03. What is the difference between the Mineral Rent(as % of GDP) in Senegal in 1983 and the Mineral Rent(as % of GDP) in Suriname in 1986?
Provide a succinct answer. -8.7. What is the difference between the Mineral Rent(as % of GDP) in Middle East & North Africa (developing only) in 1983 and the Mineral Rent(as % of GDP) in Congo (Democratic) in 1989?
Give a very brief answer. -9.58. What is the difference between the Mineral Rent(as % of GDP) of Middle East & North Africa (developing only) in 1983 and the Mineral Rent(as % of GDP) of Senegal in 1989?
Your answer should be compact. 0.03. What is the difference between the Mineral Rent(as % of GDP) in Middle East & North Africa (developing only) in 1983 and the Mineral Rent(as % of GDP) in Suriname in 1989?
Give a very brief answer. -13.78. What is the difference between the Mineral Rent(as % of GDP) of Congo (Democratic) in 1983 and the Mineral Rent(as % of GDP) of Senegal in 1989?
Keep it short and to the point. 3.89. What is the difference between the Mineral Rent(as % of GDP) of Congo (Democratic) in 1983 and the Mineral Rent(as % of GDP) of Suriname in 1989?
Your response must be concise. -9.92. What is the difference between the Mineral Rent(as % of GDP) in Senegal in 1983 and the Mineral Rent(as % of GDP) in Suriname in 1989?
Your answer should be compact. -13.59. What is the difference between the Mineral Rent(as % of GDP) of Middle East & North Africa (developing only) in 1984 and the Mineral Rent(as % of GDP) of Congo (Democratic) in 1985?
Keep it short and to the point. -4.8. What is the difference between the Mineral Rent(as % of GDP) in Middle East & North Africa (developing only) in 1984 and the Mineral Rent(as % of GDP) in Senegal in 1985?
Your answer should be compact. -0.15. What is the difference between the Mineral Rent(as % of GDP) of Middle East & North Africa (developing only) in 1984 and the Mineral Rent(as % of GDP) of Suriname in 1985?
Provide a succinct answer. -10.62. What is the difference between the Mineral Rent(as % of GDP) in Congo (Democratic) in 1984 and the Mineral Rent(as % of GDP) in Senegal in 1985?
Your response must be concise. 4.2. What is the difference between the Mineral Rent(as % of GDP) of Congo (Democratic) in 1984 and the Mineral Rent(as % of GDP) of Suriname in 1985?
Provide a succinct answer. -6.26. What is the difference between the Mineral Rent(as % of GDP) in Senegal in 1984 and the Mineral Rent(as % of GDP) in Suriname in 1985?
Your answer should be very brief. -10.13. What is the difference between the Mineral Rent(as % of GDP) in Middle East & North Africa (developing only) in 1984 and the Mineral Rent(as % of GDP) in Congo (Democratic) in 1986?
Ensure brevity in your answer.  -3.35. What is the difference between the Mineral Rent(as % of GDP) in Middle East & North Africa (developing only) in 1984 and the Mineral Rent(as % of GDP) in Senegal in 1986?
Make the answer very short. 0.1. What is the difference between the Mineral Rent(as % of GDP) in Middle East & North Africa (developing only) in 1984 and the Mineral Rent(as % of GDP) in Suriname in 1986?
Make the answer very short. -8.88. What is the difference between the Mineral Rent(as % of GDP) in Congo (Democratic) in 1984 and the Mineral Rent(as % of GDP) in Senegal in 1986?
Make the answer very short. 4.46. What is the difference between the Mineral Rent(as % of GDP) of Congo (Democratic) in 1984 and the Mineral Rent(as % of GDP) of Suriname in 1986?
Offer a terse response. -4.52. What is the difference between the Mineral Rent(as % of GDP) of Senegal in 1984 and the Mineral Rent(as % of GDP) of Suriname in 1986?
Make the answer very short. -8.39. What is the difference between the Mineral Rent(as % of GDP) in Middle East & North Africa (developing only) in 1984 and the Mineral Rent(as % of GDP) in Congo (Democratic) in 1989?
Provide a short and direct response. -9.56. What is the difference between the Mineral Rent(as % of GDP) of Middle East & North Africa (developing only) in 1984 and the Mineral Rent(as % of GDP) of Senegal in 1989?
Offer a terse response. 0.05. What is the difference between the Mineral Rent(as % of GDP) in Middle East & North Africa (developing only) in 1984 and the Mineral Rent(as % of GDP) in Suriname in 1989?
Offer a very short reply. -13.76. What is the difference between the Mineral Rent(as % of GDP) in Congo (Democratic) in 1984 and the Mineral Rent(as % of GDP) in Senegal in 1989?
Offer a terse response. 4.4. What is the difference between the Mineral Rent(as % of GDP) of Congo (Democratic) in 1984 and the Mineral Rent(as % of GDP) of Suriname in 1989?
Your answer should be very brief. -9.41. What is the difference between the Mineral Rent(as % of GDP) of Senegal in 1984 and the Mineral Rent(as % of GDP) of Suriname in 1989?
Give a very brief answer. -13.28. What is the difference between the Mineral Rent(as % of GDP) in Middle East & North Africa (developing only) in 1985 and the Mineral Rent(as % of GDP) in Congo (Democratic) in 1986?
Provide a short and direct response. -3.39. What is the difference between the Mineral Rent(as % of GDP) of Middle East & North Africa (developing only) in 1985 and the Mineral Rent(as % of GDP) of Senegal in 1986?
Your answer should be very brief. 0.07. What is the difference between the Mineral Rent(as % of GDP) in Middle East & North Africa (developing only) in 1985 and the Mineral Rent(as % of GDP) in Suriname in 1986?
Your response must be concise. -8.91. What is the difference between the Mineral Rent(as % of GDP) of Congo (Democratic) in 1985 and the Mineral Rent(as % of GDP) of Senegal in 1986?
Give a very brief answer. 4.91. What is the difference between the Mineral Rent(as % of GDP) in Congo (Democratic) in 1985 and the Mineral Rent(as % of GDP) in Suriname in 1986?
Give a very brief answer. -4.07. What is the difference between the Mineral Rent(as % of GDP) of Senegal in 1985 and the Mineral Rent(as % of GDP) of Suriname in 1986?
Your answer should be very brief. -8.73. What is the difference between the Mineral Rent(as % of GDP) in Middle East & North Africa (developing only) in 1985 and the Mineral Rent(as % of GDP) in Congo (Democratic) in 1989?
Provide a short and direct response. -9.6. What is the difference between the Mineral Rent(as % of GDP) of Middle East & North Africa (developing only) in 1985 and the Mineral Rent(as % of GDP) of Senegal in 1989?
Provide a succinct answer. 0.01. What is the difference between the Mineral Rent(as % of GDP) in Middle East & North Africa (developing only) in 1985 and the Mineral Rent(as % of GDP) in Suriname in 1989?
Provide a short and direct response. -13.8. What is the difference between the Mineral Rent(as % of GDP) in Congo (Democratic) in 1985 and the Mineral Rent(as % of GDP) in Senegal in 1989?
Give a very brief answer. 4.85. What is the difference between the Mineral Rent(as % of GDP) in Congo (Democratic) in 1985 and the Mineral Rent(as % of GDP) in Suriname in 1989?
Your answer should be compact. -8.96. What is the difference between the Mineral Rent(as % of GDP) of Senegal in 1985 and the Mineral Rent(as % of GDP) of Suriname in 1989?
Your answer should be compact. -13.61. What is the difference between the Mineral Rent(as % of GDP) of Middle East & North Africa (developing only) in 1986 and the Mineral Rent(as % of GDP) of Congo (Democratic) in 1989?
Provide a succinct answer. -9.65. What is the difference between the Mineral Rent(as % of GDP) in Middle East & North Africa (developing only) in 1986 and the Mineral Rent(as % of GDP) in Senegal in 1989?
Your response must be concise. -0.04. What is the difference between the Mineral Rent(as % of GDP) of Middle East & North Africa (developing only) in 1986 and the Mineral Rent(as % of GDP) of Suriname in 1989?
Your response must be concise. -13.85. What is the difference between the Mineral Rent(as % of GDP) of Congo (Democratic) in 1986 and the Mineral Rent(as % of GDP) of Senegal in 1989?
Your answer should be very brief. 3.4. What is the difference between the Mineral Rent(as % of GDP) in Congo (Democratic) in 1986 and the Mineral Rent(as % of GDP) in Suriname in 1989?
Give a very brief answer. -10.41. What is the difference between the Mineral Rent(as % of GDP) in Senegal in 1986 and the Mineral Rent(as % of GDP) in Suriname in 1989?
Your response must be concise. -13.87. What is the average Mineral Rent(as % of GDP) in Middle East & North Africa (developing only) per year?
Offer a terse response. 0.13. What is the average Mineral Rent(as % of GDP) of Congo (Democratic) per year?
Make the answer very short. 4.74. What is the average Mineral Rent(as % of GDP) of Senegal per year?
Provide a short and direct response. 0.41. What is the average Mineral Rent(as % of GDP) of Suriname per year?
Make the answer very short. 10.7. In the year 1980, what is the difference between the Mineral Rent(as % of GDP) of Middle East & North Africa (developing only) and Mineral Rent(as % of GDP) of Congo (Democratic)?
Provide a succinct answer. -4.57. In the year 1980, what is the difference between the Mineral Rent(as % of GDP) in Middle East & North Africa (developing only) and Mineral Rent(as % of GDP) in Senegal?
Make the answer very short. -0.41. In the year 1980, what is the difference between the Mineral Rent(as % of GDP) in Middle East & North Africa (developing only) and Mineral Rent(as % of GDP) in Suriname?
Ensure brevity in your answer.  -12.4. In the year 1980, what is the difference between the Mineral Rent(as % of GDP) of Congo (Democratic) and Mineral Rent(as % of GDP) of Senegal?
Provide a succinct answer. 4.16. In the year 1980, what is the difference between the Mineral Rent(as % of GDP) of Congo (Democratic) and Mineral Rent(as % of GDP) of Suriname?
Your response must be concise. -7.83. In the year 1980, what is the difference between the Mineral Rent(as % of GDP) of Senegal and Mineral Rent(as % of GDP) of Suriname?
Make the answer very short. -11.99. In the year 1981, what is the difference between the Mineral Rent(as % of GDP) of Middle East & North Africa (developing only) and Mineral Rent(as % of GDP) of Congo (Democratic)?
Keep it short and to the point. -3.74. In the year 1981, what is the difference between the Mineral Rent(as % of GDP) of Middle East & North Africa (developing only) and Mineral Rent(as % of GDP) of Senegal?
Provide a succinct answer. -0.82. In the year 1981, what is the difference between the Mineral Rent(as % of GDP) of Middle East & North Africa (developing only) and Mineral Rent(as % of GDP) of Suriname?
Your answer should be compact. -10.82. In the year 1981, what is the difference between the Mineral Rent(as % of GDP) in Congo (Democratic) and Mineral Rent(as % of GDP) in Senegal?
Your answer should be compact. 2.92. In the year 1981, what is the difference between the Mineral Rent(as % of GDP) in Congo (Democratic) and Mineral Rent(as % of GDP) in Suriname?
Provide a short and direct response. -7.08. In the year 1981, what is the difference between the Mineral Rent(as % of GDP) in Senegal and Mineral Rent(as % of GDP) in Suriname?
Your response must be concise. -10. In the year 1982, what is the difference between the Mineral Rent(as % of GDP) in Middle East & North Africa (developing only) and Mineral Rent(as % of GDP) in Congo (Democratic)?
Your answer should be very brief. -2.54. In the year 1982, what is the difference between the Mineral Rent(as % of GDP) of Middle East & North Africa (developing only) and Mineral Rent(as % of GDP) of Senegal?
Provide a short and direct response. -0.2. In the year 1982, what is the difference between the Mineral Rent(as % of GDP) in Middle East & North Africa (developing only) and Mineral Rent(as % of GDP) in Suriname?
Keep it short and to the point. -9.59. In the year 1982, what is the difference between the Mineral Rent(as % of GDP) of Congo (Democratic) and Mineral Rent(as % of GDP) of Senegal?
Ensure brevity in your answer.  2.34. In the year 1982, what is the difference between the Mineral Rent(as % of GDP) in Congo (Democratic) and Mineral Rent(as % of GDP) in Suriname?
Make the answer very short. -7.06. In the year 1982, what is the difference between the Mineral Rent(as % of GDP) of Senegal and Mineral Rent(as % of GDP) of Suriname?
Your answer should be compact. -9.39. In the year 1983, what is the difference between the Mineral Rent(as % of GDP) in Middle East & North Africa (developing only) and Mineral Rent(as % of GDP) in Congo (Democratic)?
Offer a very short reply. -3.86. In the year 1983, what is the difference between the Mineral Rent(as % of GDP) of Middle East & North Africa (developing only) and Mineral Rent(as % of GDP) of Senegal?
Offer a very short reply. -0.19. In the year 1983, what is the difference between the Mineral Rent(as % of GDP) in Middle East & North Africa (developing only) and Mineral Rent(as % of GDP) in Suriname?
Your response must be concise. -8.26. In the year 1983, what is the difference between the Mineral Rent(as % of GDP) of Congo (Democratic) and Mineral Rent(as % of GDP) of Senegal?
Offer a terse response. 3.67. In the year 1983, what is the difference between the Mineral Rent(as % of GDP) of Congo (Democratic) and Mineral Rent(as % of GDP) of Suriname?
Provide a succinct answer. -4.4. In the year 1983, what is the difference between the Mineral Rent(as % of GDP) of Senegal and Mineral Rent(as % of GDP) of Suriname?
Offer a terse response. -8.07. In the year 1984, what is the difference between the Mineral Rent(as % of GDP) in Middle East & North Africa (developing only) and Mineral Rent(as % of GDP) in Congo (Democratic)?
Keep it short and to the point. -4.35. In the year 1984, what is the difference between the Mineral Rent(as % of GDP) in Middle East & North Africa (developing only) and Mineral Rent(as % of GDP) in Senegal?
Your answer should be compact. -0.48. In the year 1984, what is the difference between the Mineral Rent(as % of GDP) in Middle East & North Africa (developing only) and Mineral Rent(as % of GDP) in Suriname?
Ensure brevity in your answer.  -10.14. In the year 1984, what is the difference between the Mineral Rent(as % of GDP) in Congo (Democratic) and Mineral Rent(as % of GDP) in Senegal?
Your answer should be very brief. 3.87. In the year 1984, what is the difference between the Mineral Rent(as % of GDP) in Congo (Democratic) and Mineral Rent(as % of GDP) in Suriname?
Your answer should be compact. -5.79. In the year 1984, what is the difference between the Mineral Rent(as % of GDP) in Senegal and Mineral Rent(as % of GDP) in Suriname?
Your answer should be compact. -9.66. In the year 1985, what is the difference between the Mineral Rent(as % of GDP) of Middle East & North Africa (developing only) and Mineral Rent(as % of GDP) of Congo (Democratic)?
Provide a short and direct response. -4.84. In the year 1985, what is the difference between the Mineral Rent(as % of GDP) of Middle East & North Africa (developing only) and Mineral Rent(as % of GDP) of Senegal?
Your answer should be very brief. -0.19. In the year 1985, what is the difference between the Mineral Rent(as % of GDP) in Middle East & North Africa (developing only) and Mineral Rent(as % of GDP) in Suriname?
Your answer should be very brief. -10.65. In the year 1985, what is the difference between the Mineral Rent(as % of GDP) in Congo (Democratic) and Mineral Rent(as % of GDP) in Senegal?
Your answer should be very brief. 4.65. In the year 1985, what is the difference between the Mineral Rent(as % of GDP) of Congo (Democratic) and Mineral Rent(as % of GDP) of Suriname?
Provide a short and direct response. -5.81. In the year 1985, what is the difference between the Mineral Rent(as % of GDP) of Senegal and Mineral Rent(as % of GDP) of Suriname?
Offer a terse response. -10.46. In the year 1986, what is the difference between the Mineral Rent(as % of GDP) of Middle East & North Africa (developing only) and Mineral Rent(as % of GDP) of Congo (Democratic)?
Your answer should be compact. -3.44. In the year 1986, what is the difference between the Mineral Rent(as % of GDP) of Middle East & North Africa (developing only) and Mineral Rent(as % of GDP) of Senegal?
Keep it short and to the point. 0.02. In the year 1986, what is the difference between the Mineral Rent(as % of GDP) in Middle East & North Africa (developing only) and Mineral Rent(as % of GDP) in Suriname?
Give a very brief answer. -8.96. In the year 1986, what is the difference between the Mineral Rent(as % of GDP) in Congo (Democratic) and Mineral Rent(as % of GDP) in Senegal?
Your answer should be very brief. 3.46. In the year 1986, what is the difference between the Mineral Rent(as % of GDP) of Congo (Democratic) and Mineral Rent(as % of GDP) of Suriname?
Offer a terse response. -5.52. In the year 1986, what is the difference between the Mineral Rent(as % of GDP) of Senegal and Mineral Rent(as % of GDP) of Suriname?
Keep it short and to the point. -8.98. In the year 1989, what is the difference between the Mineral Rent(as % of GDP) of Middle East & North Africa (developing only) and Mineral Rent(as % of GDP) of Congo (Democratic)?
Your answer should be very brief. -9.56. In the year 1989, what is the difference between the Mineral Rent(as % of GDP) of Middle East & North Africa (developing only) and Mineral Rent(as % of GDP) of Senegal?
Keep it short and to the point. 0.05. In the year 1989, what is the difference between the Mineral Rent(as % of GDP) of Middle East & North Africa (developing only) and Mineral Rent(as % of GDP) of Suriname?
Offer a very short reply. -13.76. In the year 1989, what is the difference between the Mineral Rent(as % of GDP) of Congo (Democratic) and Mineral Rent(as % of GDP) of Senegal?
Provide a short and direct response. 9.61. In the year 1989, what is the difference between the Mineral Rent(as % of GDP) of Congo (Democratic) and Mineral Rent(as % of GDP) of Suriname?
Your answer should be very brief. -4.2. In the year 1989, what is the difference between the Mineral Rent(as % of GDP) of Senegal and Mineral Rent(as % of GDP) of Suriname?
Your response must be concise. -13.81. What is the ratio of the Mineral Rent(as % of GDP) in Middle East & North Africa (developing only) in 1980 to that in 1981?
Your response must be concise. 0.86. What is the ratio of the Mineral Rent(as % of GDP) of Congo (Democratic) in 1980 to that in 1981?
Ensure brevity in your answer.  1.2. What is the ratio of the Mineral Rent(as % of GDP) in Senegal in 1980 to that in 1981?
Your answer should be compact. 0.58. What is the ratio of the Mineral Rent(as % of GDP) in Suriname in 1980 to that in 1981?
Your answer should be very brief. 1.14. What is the ratio of the Mineral Rent(as % of GDP) in Middle East & North Africa (developing only) in 1980 to that in 1982?
Make the answer very short. 1.31. What is the ratio of the Mineral Rent(as % of GDP) of Congo (Democratic) in 1980 to that in 1982?
Keep it short and to the point. 1.77. What is the ratio of the Mineral Rent(as % of GDP) of Senegal in 1980 to that in 1982?
Offer a very short reply. 1.73. What is the ratio of the Mineral Rent(as % of GDP) of Suriname in 1980 to that in 1982?
Give a very brief answer. 1.29. What is the ratio of the Mineral Rent(as % of GDP) of Middle East & North Africa (developing only) in 1980 to that in 1983?
Your answer should be compact. 1.94. What is the ratio of the Mineral Rent(as % of GDP) in Congo (Democratic) in 1980 to that in 1983?
Provide a short and direct response. 1.2. What is the ratio of the Mineral Rent(as % of GDP) of Senegal in 1980 to that in 1983?
Ensure brevity in your answer.  2.06. What is the ratio of the Mineral Rent(as % of GDP) of Suriname in 1980 to that in 1983?
Make the answer very short. 1.51. What is the ratio of the Mineral Rent(as % of GDP) of Middle East & North Africa (developing only) in 1980 to that in 1984?
Keep it short and to the point. 1.64. What is the ratio of the Mineral Rent(as % of GDP) in Congo (Democratic) in 1980 to that in 1984?
Provide a short and direct response. 1.06. What is the ratio of the Mineral Rent(as % of GDP) of Senegal in 1980 to that in 1984?
Offer a terse response. 1.01. What is the ratio of the Mineral Rent(as % of GDP) in Suriname in 1980 to that in 1984?
Your answer should be compact. 1.23. What is the ratio of the Mineral Rent(as % of GDP) of Middle East & North Africa (developing only) in 1980 to that in 1985?
Provide a short and direct response. 2.3. What is the ratio of the Mineral Rent(as % of GDP) of Congo (Democratic) in 1980 to that in 1985?
Make the answer very short. 0.97. What is the ratio of the Mineral Rent(as % of GDP) of Senegal in 1980 to that in 1985?
Make the answer very short. 2.24. What is the ratio of the Mineral Rent(as % of GDP) in Suriname in 1980 to that in 1985?
Your answer should be very brief. 1.17. What is the ratio of the Mineral Rent(as % of GDP) of Middle East & North Africa (developing only) in 1980 to that in 1986?
Your response must be concise. 5.51. What is the ratio of the Mineral Rent(as % of GDP) of Congo (Democratic) in 1980 to that in 1986?
Your response must be concise. 1.37. What is the ratio of the Mineral Rent(as % of GDP) in Senegal in 1980 to that in 1986?
Provide a succinct answer. 33.19. What is the ratio of the Mineral Rent(as % of GDP) in Suriname in 1980 to that in 1986?
Your answer should be very brief. 1.4. What is the ratio of the Mineral Rent(as % of GDP) of Middle East & North Africa (developing only) in 1980 to that in 1989?
Your response must be concise. 1.59. What is the ratio of the Mineral Rent(as % of GDP) in Congo (Democratic) in 1980 to that in 1989?
Your answer should be very brief. 0.49. What is the ratio of the Mineral Rent(as % of GDP) in Senegal in 1980 to that in 1989?
Keep it short and to the point. 8.16. What is the ratio of the Mineral Rent(as % of GDP) in Suriname in 1980 to that in 1989?
Offer a terse response. 0.91. What is the ratio of the Mineral Rent(as % of GDP) in Middle East & North Africa (developing only) in 1981 to that in 1982?
Give a very brief answer. 1.51. What is the ratio of the Mineral Rent(as % of GDP) in Congo (Democratic) in 1981 to that in 1982?
Your answer should be very brief. 1.48. What is the ratio of the Mineral Rent(as % of GDP) in Senegal in 1981 to that in 1982?
Offer a very short reply. 3. What is the ratio of the Mineral Rent(as % of GDP) in Suriname in 1981 to that in 1982?
Your answer should be compact. 1.13. What is the ratio of the Mineral Rent(as % of GDP) of Middle East & North Africa (developing only) in 1981 to that in 1983?
Keep it short and to the point. 2.25. What is the ratio of the Mineral Rent(as % of GDP) of Senegal in 1981 to that in 1983?
Provide a short and direct response. 3.57. What is the ratio of the Mineral Rent(as % of GDP) of Suriname in 1981 to that in 1983?
Your answer should be compact. 1.32. What is the ratio of the Mineral Rent(as % of GDP) of Middle East & North Africa (developing only) in 1981 to that in 1984?
Provide a succinct answer. 1.9. What is the ratio of the Mineral Rent(as % of GDP) in Congo (Democratic) in 1981 to that in 1984?
Make the answer very short. 0.89. What is the ratio of the Mineral Rent(as % of GDP) of Senegal in 1981 to that in 1984?
Your answer should be very brief. 1.74. What is the ratio of the Mineral Rent(as % of GDP) in Suriname in 1981 to that in 1984?
Offer a very short reply. 1.08. What is the ratio of the Mineral Rent(as % of GDP) in Middle East & North Africa (developing only) in 1981 to that in 1985?
Make the answer very short. 2.67. What is the ratio of the Mineral Rent(as % of GDP) of Congo (Democratic) in 1981 to that in 1985?
Your answer should be compact. 0.81. What is the ratio of the Mineral Rent(as % of GDP) of Senegal in 1981 to that in 1985?
Your answer should be very brief. 3.87. What is the ratio of the Mineral Rent(as % of GDP) in Suriname in 1981 to that in 1985?
Ensure brevity in your answer.  1.03. What is the ratio of the Mineral Rent(as % of GDP) in Middle East & North Africa (developing only) in 1981 to that in 1986?
Offer a terse response. 6.38. What is the ratio of the Mineral Rent(as % of GDP) in Congo (Democratic) in 1981 to that in 1986?
Give a very brief answer. 1.14. What is the ratio of the Mineral Rent(as % of GDP) in Senegal in 1981 to that in 1986?
Provide a short and direct response. 57.49. What is the ratio of the Mineral Rent(as % of GDP) of Suriname in 1981 to that in 1986?
Provide a short and direct response. 1.23. What is the ratio of the Mineral Rent(as % of GDP) in Middle East & North Africa (developing only) in 1981 to that in 1989?
Offer a very short reply. 1.84. What is the ratio of the Mineral Rent(as % of GDP) of Congo (Democratic) in 1981 to that in 1989?
Keep it short and to the point. 0.41. What is the ratio of the Mineral Rent(as % of GDP) in Senegal in 1981 to that in 1989?
Your response must be concise. 14.13. What is the ratio of the Mineral Rent(as % of GDP) of Suriname in 1981 to that in 1989?
Offer a very short reply. 0.8. What is the ratio of the Mineral Rent(as % of GDP) in Middle East & North Africa (developing only) in 1982 to that in 1983?
Keep it short and to the point. 1.49. What is the ratio of the Mineral Rent(as % of GDP) in Congo (Democratic) in 1982 to that in 1983?
Give a very brief answer. 0.68. What is the ratio of the Mineral Rent(as % of GDP) of Senegal in 1982 to that in 1983?
Make the answer very short. 1.19. What is the ratio of the Mineral Rent(as % of GDP) of Suriname in 1982 to that in 1983?
Your response must be concise. 1.17. What is the ratio of the Mineral Rent(as % of GDP) in Middle East & North Africa (developing only) in 1982 to that in 1984?
Your answer should be compact. 1.26. What is the ratio of the Mineral Rent(as % of GDP) in Congo (Democratic) in 1982 to that in 1984?
Keep it short and to the point. 0.6. What is the ratio of the Mineral Rent(as % of GDP) of Senegal in 1982 to that in 1984?
Offer a terse response. 0.58. What is the ratio of the Mineral Rent(as % of GDP) of Suriname in 1982 to that in 1984?
Offer a terse response. 0.95. What is the ratio of the Mineral Rent(as % of GDP) in Middle East & North Africa (developing only) in 1982 to that in 1985?
Keep it short and to the point. 1.76. What is the ratio of the Mineral Rent(as % of GDP) of Congo (Democratic) in 1982 to that in 1985?
Your response must be concise. 0.55. What is the ratio of the Mineral Rent(as % of GDP) in Senegal in 1982 to that in 1985?
Provide a succinct answer. 1.29. What is the ratio of the Mineral Rent(as % of GDP) of Suriname in 1982 to that in 1985?
Offer a terse response. 0.91. What is the ratio of the Mineral Rent(as % of GDP) of Middle East & North Africa (developing only) in 1982 to that in 1986?
Your answer should be very brief. 4.22. What is the ratio of the Mineral Rent(as % of GDP) of Congo (Democratic) in 1982 to that in 1986?
Your answer should be very brief. 0.77. What is the ratio of the Mineral Rent(as % of GDP) of Senegal in 1982 to that in 1986?
Make the answer very short. 19.14. What is the ratio of the Mineral Rent(as % of GDP) of Suriname in 1982 to that in 1986?
Your response must be concise. 1.08. What is the ratio of the Mineral Rent(as % of GDP) in Middle East & North Africa (developing only) in 1982 to that in 1989?
Provide a succinct answer. 1.21. What is the ratio of the Mineral Rent(as % of GDP) of Congo (Democratic) in 1982 to that in 1989?
Provide a succinct answer. 0.28. What is the ratio of the Mineral Rent(as % of GDP) of Senegal in 1982 to that in 1989?
Your answer should be compact. 4.71. What is the ratio of the Mineral Rent(as % of GDP) in Suriname in 1982 to that in 1989?
Make the answer very short. 0.7. What is the ratio of the Mineral Rent(as % of GDP) of Middle East & North Africa (developing only) in 1983 to that in 1984?
Offer a very short reply. 0.85. What is the ratio of the Mineral Rent(as % of GDP) in Congo (Democratic) in 1983 to that in 1984?
Offer a very short reply. 0.89. What is the ratio of the Mineral Rent(as % of GDP) of Senegal in 1983 to that in 1984?
Make the answer very short. 0.49. What is the ratio of the Mineral Rent(as % of GDP) of Suriname in 1983 to that in 1984?
Your response must be concise. 0.81. What is the ratio of the Mineral Rent(as % of GDP) in Middle East & North Africa (developing only) in 1983 to that in 1985?
Make the answer very short. 1.19. What is the ratio of the Mineral Rent(as % of GDP) of Congo (Democratic) in 1983 to that in 1985?
Your answer should be very brief. 0.8. What is the ratio of the Mineral Rent(as % of GDP) in Senegal in 1983 to that in 1985?
Offer a terse response. 1.08. What is the ratio of the Mineral Rent(as % of GDP) of Suriname in 1983 to that in 1985?
Give a very brief answer. 0.78. What is the ratio of the Mineral Rent(as % of GDP) in Middle East & North Africa (developing only) in 1983 to that in 1986?
Ensure brevity in your answer.  2.84. What is the ratio of the Mineral Rent(as % of GDP) in Congo (Democratic) in 1983 to that in 1986?
Provide a short and direct response. 1.14. What is the ratio of the Mineral Rent(as % of GDP) of Senegal in 1983 to that in 1986?
Your response must be concise. 16.09. What is the ratio of the Mineral Rent(as % of GDP) in Suriname in 1983 to that in 1986?
Ensure brevity in your answer.  0.93. What is the ratio of the Mineral Rent(as % of GDP) in Middle East & North Africa (developing only) in 1983 to that in 1989?
Make the answer very short. 0.82. What is the ratio of the Mineral Rent(as % of GDP) of Congo (Democratic) in 1983 to that in 1989?
Your response must be concise. 0.41. What is the ratio of the Mineral Rent(as % of GDP) of Senegal in 1983 to that in 1989?
Your answer should be very brief. 3.96. What is the ratio of the Mineral Rent(as % of GDP) of Suriname in 1983 to that in 1989?
Provide a short and direct response. 0.6. What is the ratio of the Mineral Rent(as % of GDP) in Middle East & North Africa (developing only) in 1984 to that in 1985?
Keep it short and to the point. 1.4. What is the ratio of the Mineral Rent(as % of GDP) in Congo (Democratic) in 1984 to that in 1985?
Your response must be concise. 0.91. What is the ratio of the Mineral Rent(as % of GDP) in Senegal in 1984 to that in 1985?
Your answer should be very brief. 2.22. What is the ratio of the Mineral Rent(as % of GDP) in Suriname in 1984 to that in 1985?
Ensure brevity in your answer.  0.96. What is the ratio of the Mineral Rent(as % of GDP) of Middle East & North Africa (developing only) in 1984 to that in 1986?
Provide a succinct answer. 3.35. What is the ratio of the Mineral Rent(as % of GDP) of Congo (Democratic) in 1984 to that in 1986?
Keep it short and to the point. 1.29. What is the ratio of the Mineral Rent(as % of GDP) of Senegal in 1984 to that in 1986?
Give a very brief answer. 32.98. What is the ratio of the Mineral Rent(as % of GDP) of Suriname in 1984 to that in 1986?
Ensure brevity in your answer.  1.14. What is the ratio of the Mineral Rent(as % of GDP) in Middle East & North Africa (developing only) in 1984 to that in 1989?
Offer a terse response. 0.97. What is the ratio of the Mineral Rent(as % of GDP) of Congo (Democratic) in 1984 to that in 1989?
Your answer should be very brief. 0.46. What is the ratio of the Mineral Rent(as % of GDP) of Senegal in 1984 to that in 1989?
Provide a succinct answer. 8.11. What is the ratio of the Mineral Rent(as % of GDP) of Suriname in 1984 to that in 1989?
Offer a very short reply. 0.74. What is the ratio of the Mineral Rent(as % of GDP) in Middle East & North Africa (developing only) in 1985 to that in 1986?
Make the answer very short. 2.39. What is the ratio of the Mineral Rent(as % of GDP) of Congo (Democratic) in 1985 to that in 1986?
Offer a terse response. 1.42. What is the ratio of the Mineral Rent(as % of GDP) in Senegal in 1985 to that in 1986?
Offer a very short reply. 14.84. What is the ratio of the Mineral Rent(as % of GDP) of Suriname in 1985 to that in 1986?
Your response must be concise. 1.19. What is the ratio of the Mineral Rent(as % of GDP) of Middle East & North Africa (developing only) in 1985 to that in 1989?
Your answer should be compact. 0.69. What is the ratio of the Mineral Rent(as % of GDP) in Congo (Democratic) in 1985 to that in 1989?
Keep it short and to the point. 0.51. What is the ratio of the Mineral Rent(as % of GDP) of Senegal in 1985 to that in 1989?
Offer a terse response. 3.65. What is the ratio of the Mineral Rent(as % of GDP) of Suriname in 1985 to that in 1989?
Make the answer very short. 0.77. What is the ratio of the Mineral Rent(as % of GDP) of Middle East & North Africa (developing only) in 1986 to that in 1989?
Provide a succinct answer. 0.29. What is the ratio of the Mineral Rent(as % of GDP) of Congo (Democratic) in 1986 to that in 1989?
Your response must be concise. 0.36. What is the ratio of the Mineral Rent(as % of GDP) of Senegal in 1986 to that in 1989?
Give a very brief answer. 0.25. What is the ratio of the Mineral Rent(as % of GDP) of Suriname in 1986 to that in 1989?
Give a very brief answer. 0.65. What is the difference between the highest and the second highest Mineral Rent(as % of GDP) of Middle East & North Africa (developing only)?
Provide a short and direct response. 0.03. What is the difference between the highest and the second highest Mineral Rent(as % of GDP) in Congo (Democratic)?
Make the answer very short. 4.76. What is the difference between the highest and the second highest Mineral Rent(as % of GDP) of Senegal?
Your answer should be compact. 0.44. What is the difference between the highest and the second highest Mineral Rent(as % of GDP) in Suriname?
Make the answer very short. 1.29. What is the difference between the highest and the lowest Mineral Rent(as % of GDP) in Middle East & North Africa (developing only)?
Offer a terse response. 0.19. What is the difference between the highest and the lowest Mineral Rent(as % of GDP) in Congo (Democratic)?
Provide a short and direct response. 6.99. What is the difference between the highest and the lowest Mineral Rent(as % of GDP) of Senegal?
Your answer should be compact. 1.03. What is the difference between the highest and the lowest Mineral Rent(as % of GDP) in Suriname?
Ensure brevity in your answer.  5.52. 